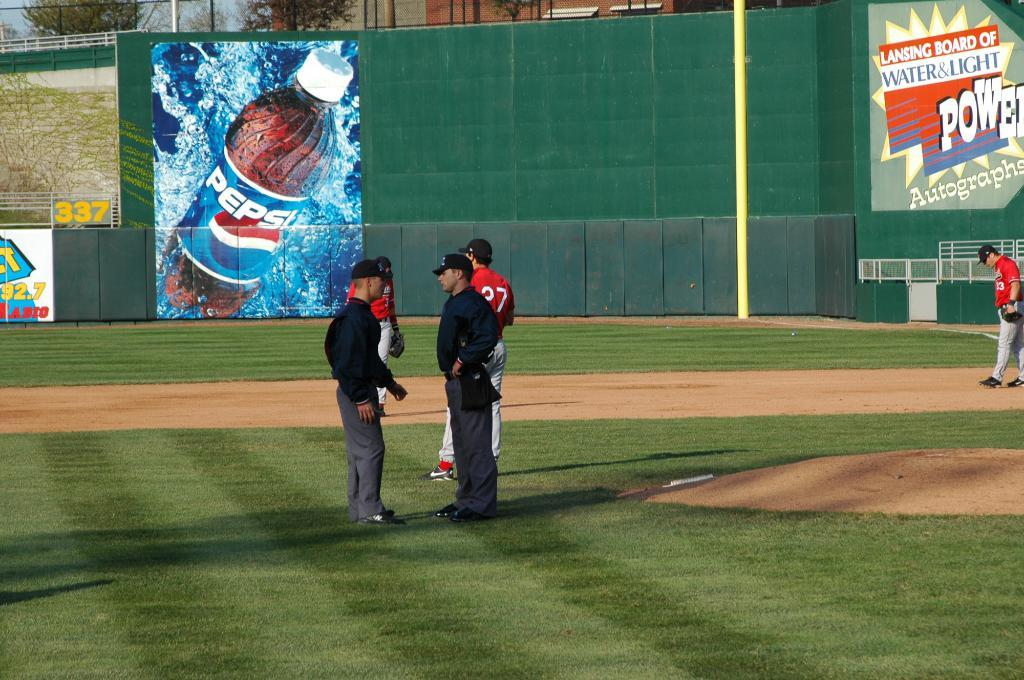<image>
Write a terse but informative summary of the picture. Umpires talk on a baseball field in front of an advertisement for Pepsi. 